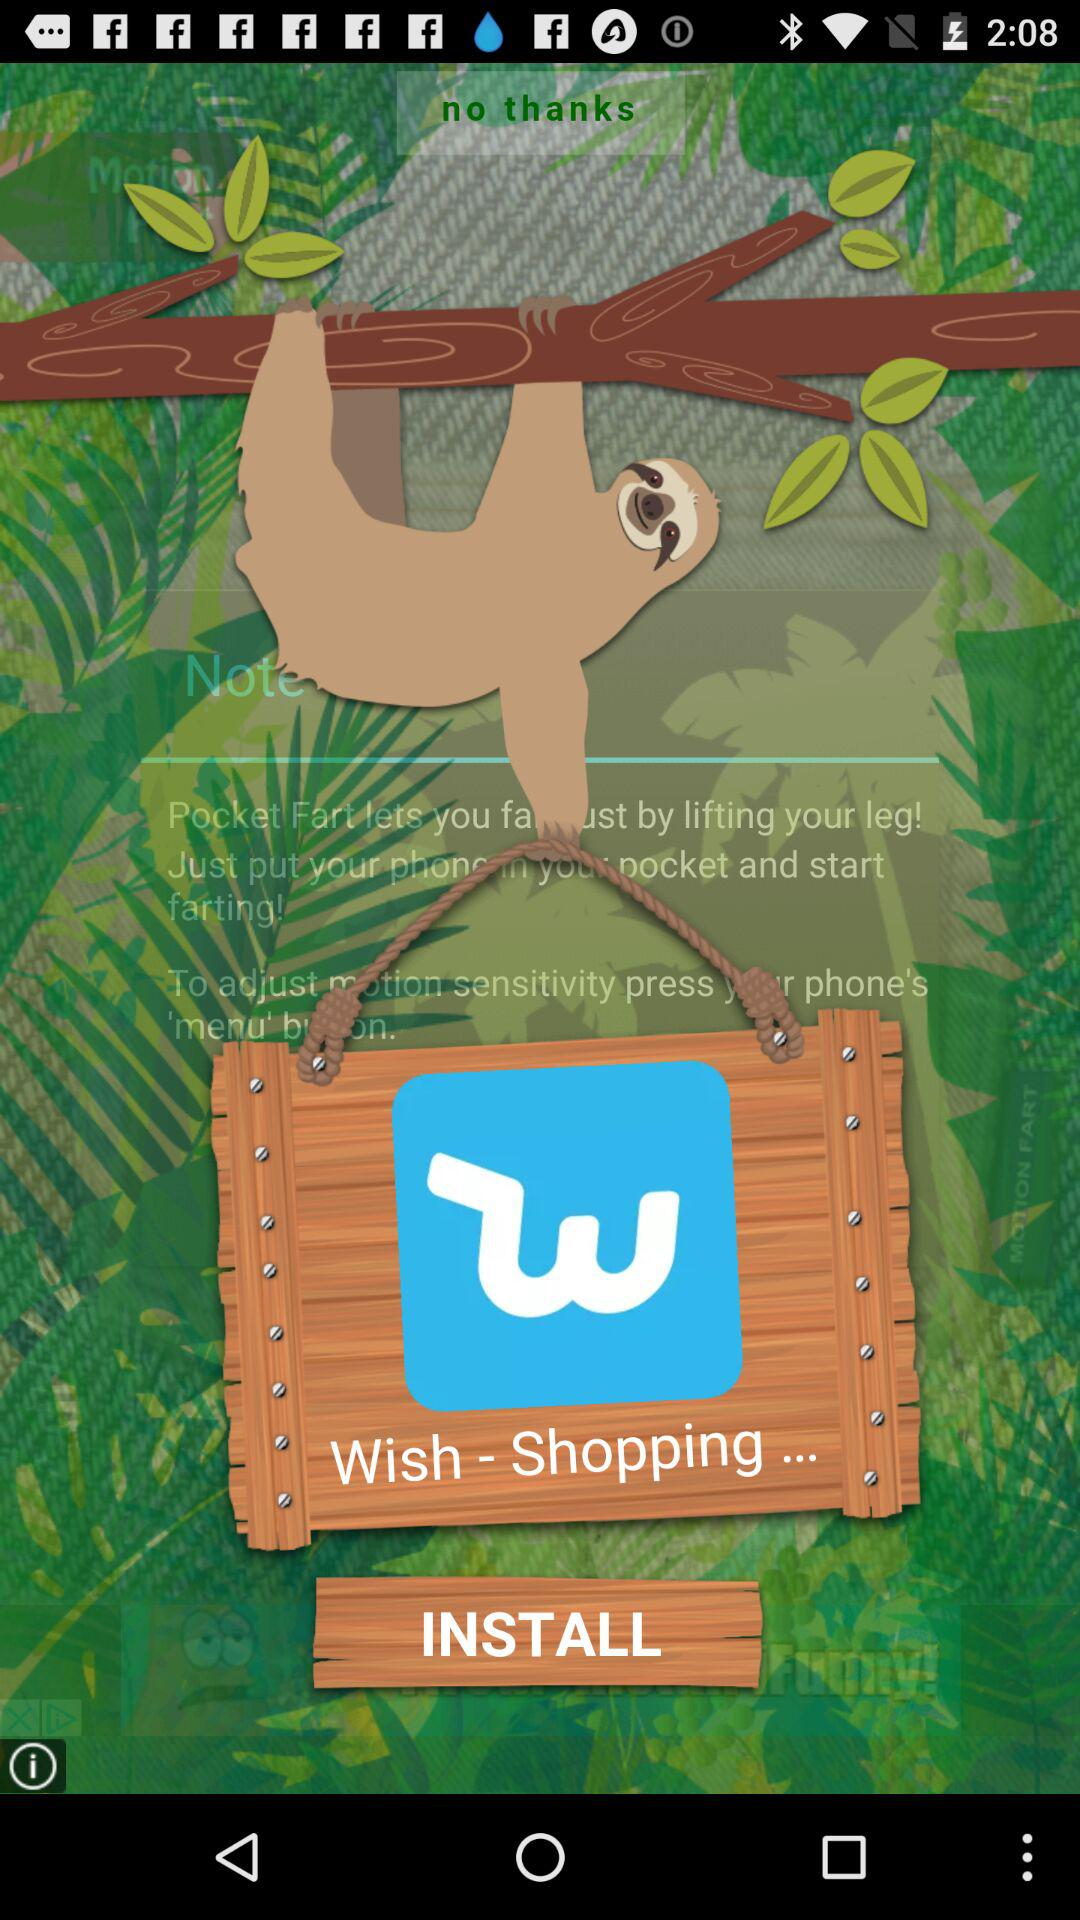What is the name of the application? The name of the application is "Wish". 